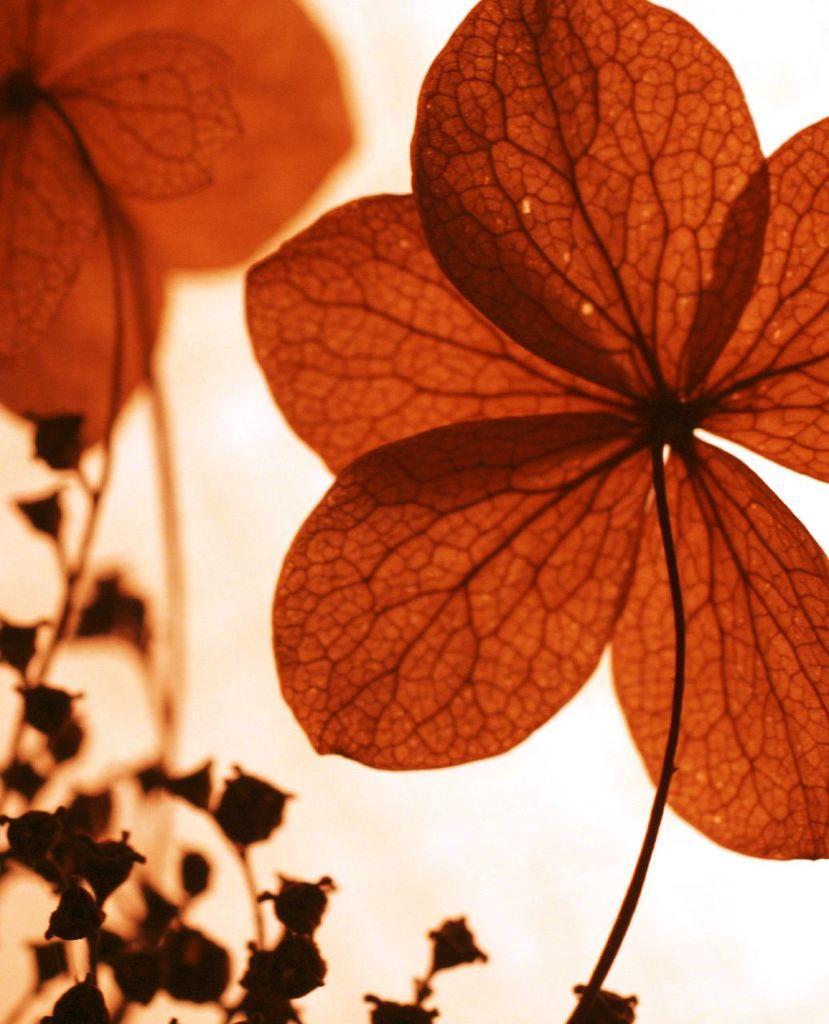Can you describe this image briefly? In the image there is a plant in the front and behind there is a light reflection. 